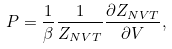<formula> <loc_0><loc_0><loc_500><loc_500>P = \frac { 1 } { \beta } \frac { 1 } { Z _ { N V T } } \frac { \partial Z _ { N V T } } { \partial V } ,</formula> 